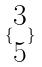Convert formula to latex. <formula><loc_0><loc_0><loc_500><loc_500>\{ \begin{matrix} 3 \\ 5 \end{matrix} \}</formula> 